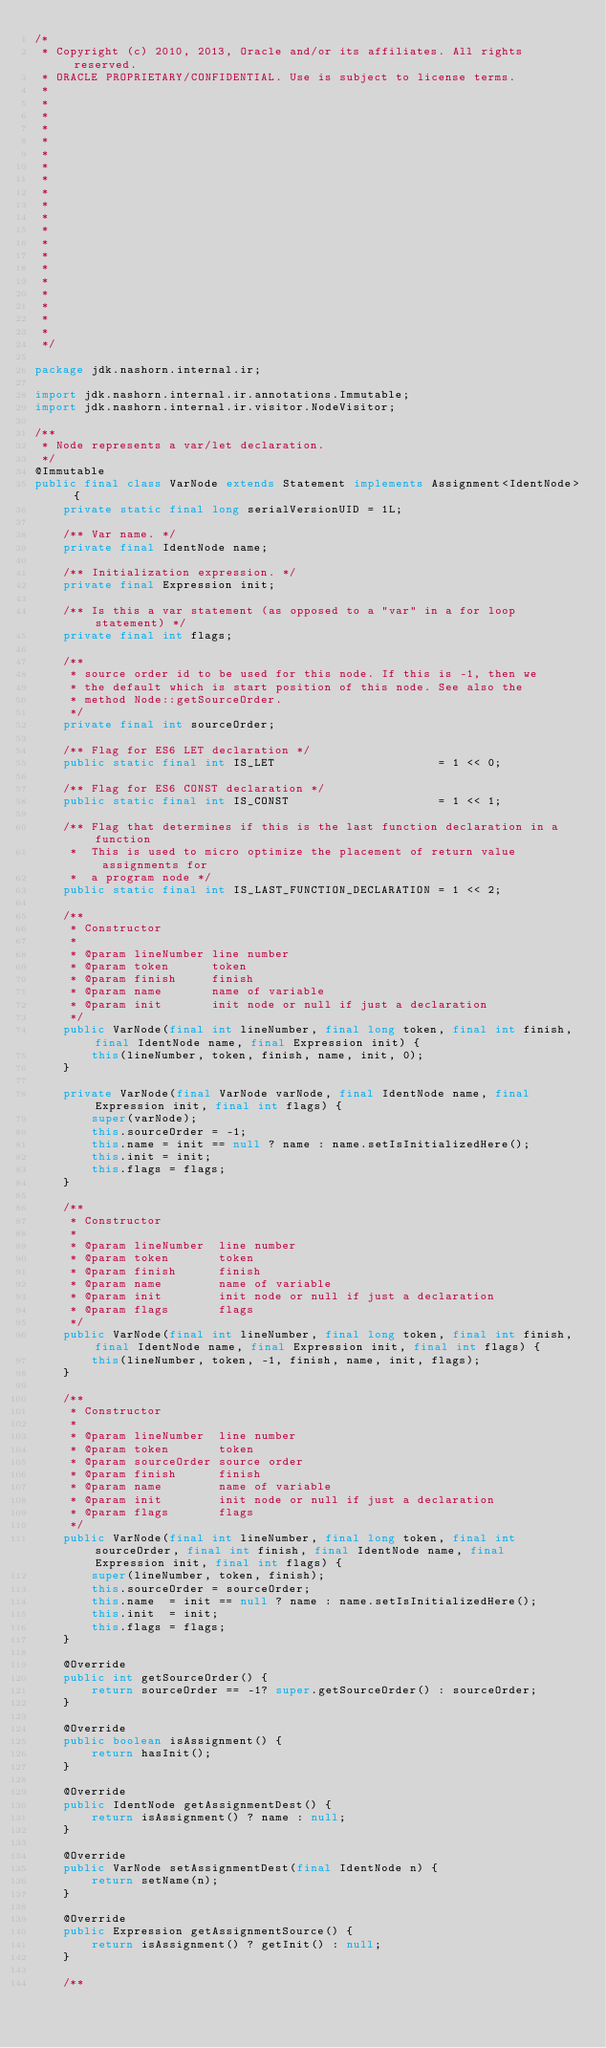Convert code to text. <code><loc_0><loc_0><loc_500><loc_500><_Java_>/*
 * Copyright (c) 2010, 2013, Oracle and/or its affiliates. All rights reserved.
 * ORACLE PROPRIETARY/CONFIDENTIAL. Use is subject to license terms.
 *
 *
 *
 *
 *
 *
 *
 *
 *
 *
 *
 *
 *
 *
 *
 *
 *
 *
 *
 *
 */

package jdk.nashorn.internal.ir;

import jdk.nashorn.internal.ir.annotations.Immutable;
import jdk.nashorn.internal.ir.visitor.NodeVisitor;

/**
 * Node represents a var/let declaration.
 */
@Immutable
public final class VarNode extends Statement implements Assignment<IdentNode> {
    private static final long serialVersionUID = 1L;

    /** Var name. */
    private final IdentNode name;

    /** Initialization expression. */
    private final Expression init;

    /** Is this a var statement (as opposed to a "var" in a for loop statement) */
    private final int flags;

    /**
     * source order id to be used for this node. If this is -1, then we
     * the default which is start position of this node. See also the
     * method Node::getSourceOrder.
     */
    private final int sourceOrder;

    /** Flag for ES6 LET declaration */
    public static final int IS_LET                       = 1 << 0;

    /** Flag for ES6 CONST declaration */
    public static final int IS_CONST                     = 1 << 1;

    /** Flag that determines if this is the last function declaration in a function
     *  This is used to micro optimize the placement of return value assignments for
     *  a program node */
    public static final int IS_LAST_FUNCTION_DECLARATION = 1 << 2;

    /**
     * Constructor
     *
     * @param lineNumber line number
     * @param token      token
     * @param finish     finish
     * @param name       name of variable
     * @param init       init node or null if just a declaration
     */
    public VarNode(final int lineNumber, final long token, final int finish, final IdentNode name, final Expression init) {
        this(lineNumber, token, finish, name, init, 0);
    }

    private VarNode(final VarNode varNode, final IdentNode name, final Expression init, final int flags) {
        super(varNode);
        this.sourceOrder = -1;
        this.name = init == null ? name : name.setIsInitializedHere();
        this.init = init;
        this.flags = flags;
    }

    /**
     * Constructor
     *
     * @param lineNumber  line number
     * @param token       token
     * @param finish      finish
     * @param name        name of variable
     * @param init        init node or null if just a declaration
     * @param flags       flags
     */
    public VarNode(final int lineNumber, final long token, final int finish, final IdentNode name, final Expression init, final int flags) {
        this(lineNumber, token, -1, finish, name, init, flags);
    }

    /**
     * Constructor
     *
     * @param lineNumber  line number
     * @param token       token
     * @param sourceOrder source order
     * @param finish      finish
     * @param name        name of variable
     * @param init        init node or null if just a declaration
     * @param flags       flags
     */
    public VarNode(final int lineNumber, final long token, final int sourceOrder, final int finish, final IdentNode name, final Expression init, final int flags) {
        super(lineNumber, token, finish);
        this.sourceOrder = sourceOrder;
        this.name  = init == null ? name : name.setIsInitializedHere();
        this.init  = init;
        this.flags = flags;
    }

    @Override
    public int getSourceOrder() {
        return sourceOrder == -1? super.getSourceOrder() : sourceOrder;
    }

    @Override
    public boolean isAssignment() {
        return hasInit();
    }

    @Override
    public IdentNode getAssignmentDest() {
        return isAssignment() ? name : null;
    }

    @Override
    public VarNode setAssignmentDest(final IdentNode n) {
        return setName(n);
    }

    @Override
    public Expression getAssignmentSource() {
        return isAssignment() ? getInit() : null;
    }

    /**</code> 